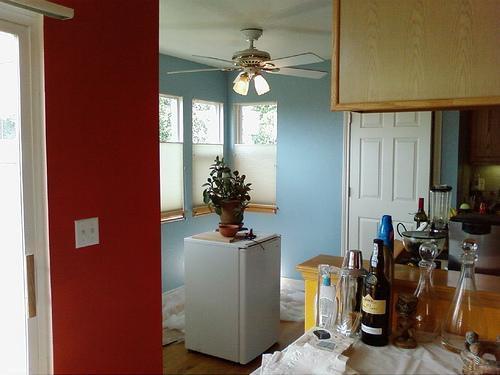What is the plant sitting on?
Select the accurate answer and provide explanation: 'Answer: answer
Rationale: rationale.'
Options: Table, trunk, microwave, refrigerator. Answer: refrigerator.
Rationale: The plant is on the fridge. What is sitting on the mini fridge in the center of the room?
Pick the right solution, then justify: 'Answer: answer
Rationale: rationale.'
Options: Potted plant, small child, adult male, hammer. Answer: potted plant.
Rationale: A small plant in a pot is on top of a small white appliance in a home. 